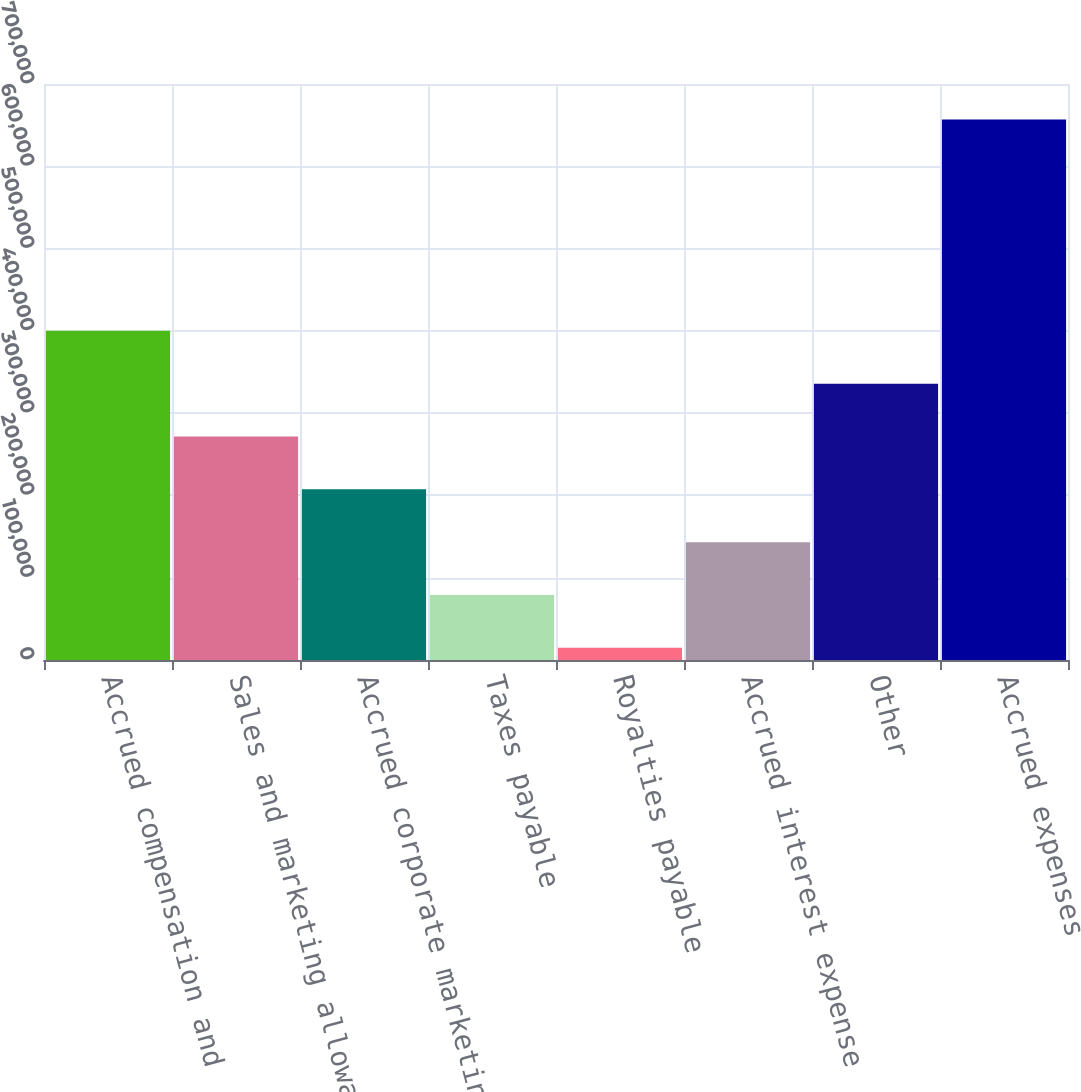<chart> <loc_0><loc_0><loc_500><loc_500><bar_chart><fcel>Accrued compensation and<fcel>Sales and marketing allowances<fcel>Accrued corporate marketing<fcel>Taxes payable<fcel>Royalties payable<fcel>Accrued interest expense<fcel>Other<fcel>Accrued expenses<nl><fcel>400075<fcel>271642<fcel>207426<fcel>78994.1<fcel>14778<fcel>143210<fcel>335858<fcel>656939<nl></chart> 